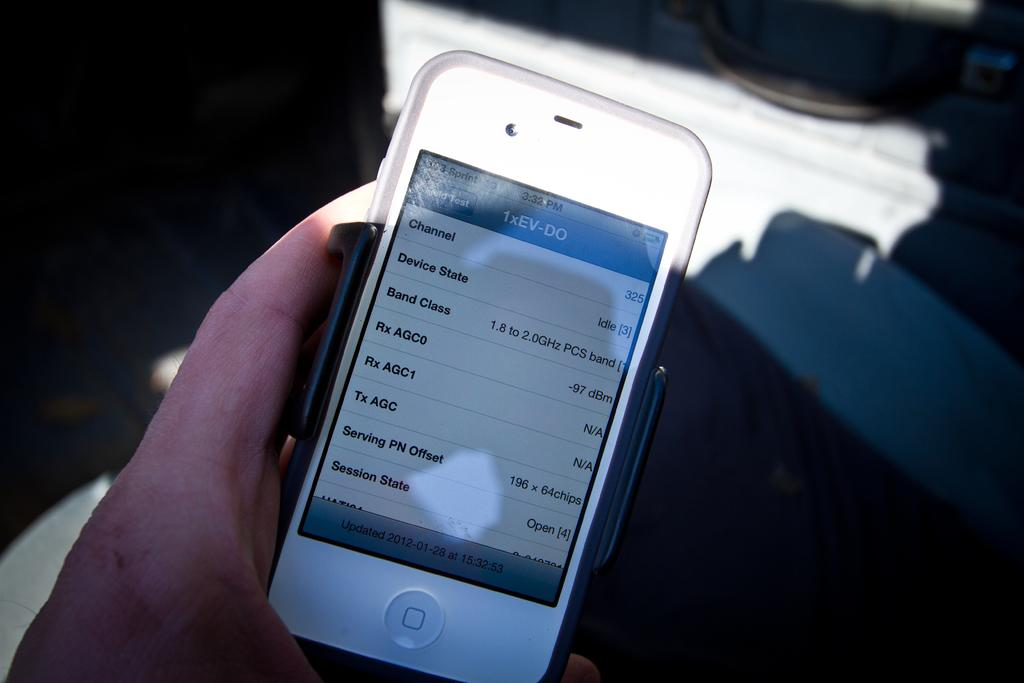What part of a person's body is visible in the image? There is a person's hand in the image. What is the person holding in the image? The person is holding a mobile. Can you describe the background of the image? The background of the image is blurred. What type of underwear is the person wearing in the image? There is no information about the person's clothing, including underwear, in the image. How many tomatoes can be seen in the image? There are no tomatoes present in the image. 